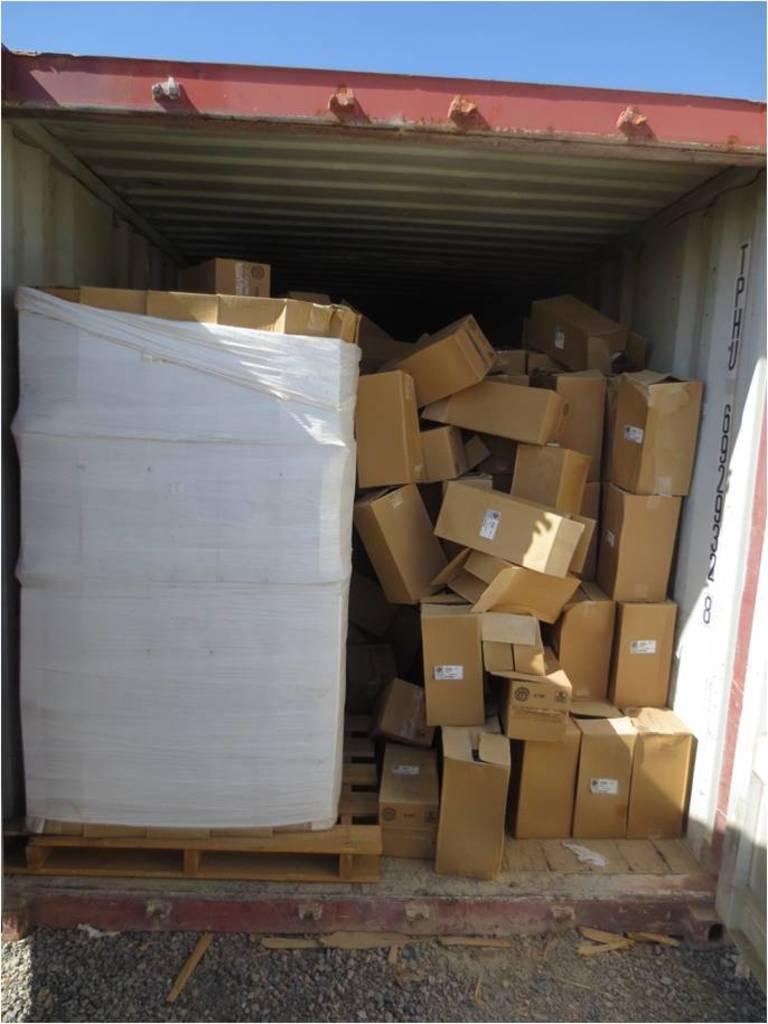Could you give a brief overview of what you see in this image? This image consists of many boxes made up of cardboard. At the bottom, there is ground. It looks like a metal cabin. At the top, there is sky. 